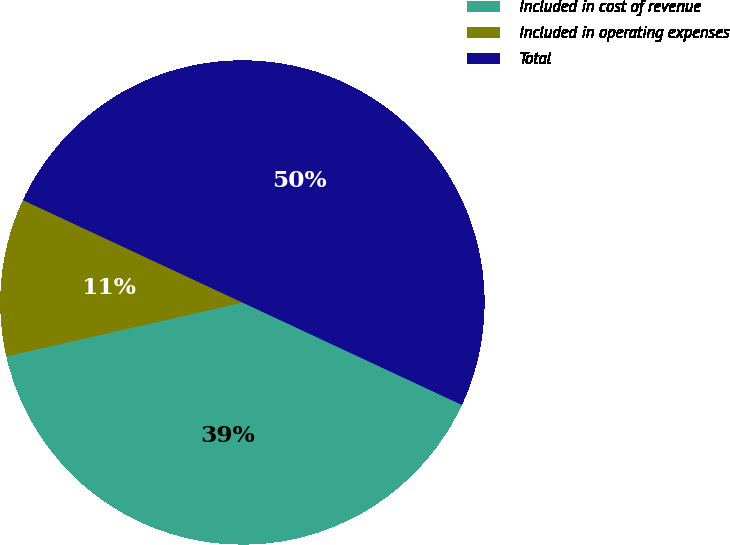Convert chart to OTSL. <chart><loc_0><loc_0><loc_500><loc_500><pie_chart><fcel>Included in cost of revenue<fcel>Included in operating expenses<fcel>Total<nl><fcel>39.48%<fcel>10.52%<fcel>50.0%<nl></chart> 